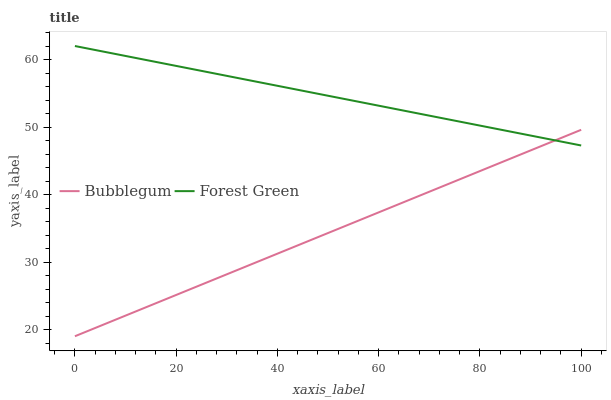Does Bubblegum have the minimum area under the curve?
Answer yes or no. Yes. Does Forest Green have the maximum area under the curve?
Answer yes or no. Yes. Does Bubblegum have the maximum area under the curve?
Answer yes or no. No. Is Bubblegum the smoothest?
Answer yes or no. Yes. Is Forest Green the roughest?
Answer yes or no. Yes. Is Bubblegum the roughest?
Answer yes or no. No. Does Bubblegum have the lowest value?
Answer yes or no. Yes. Does Forest Green have the highest value?
Answer yes or no. Yes. Does Bubblegum have the highest value?
Answer yes or no. No. Does Forest Green intersect Bubblegum?
Answer yes or no. Yes. Is Forest Green less than Bubblegum?
Answer yes or no. No. Is Forest Green greater than Bubblegum?
Answer yes or no. No. 